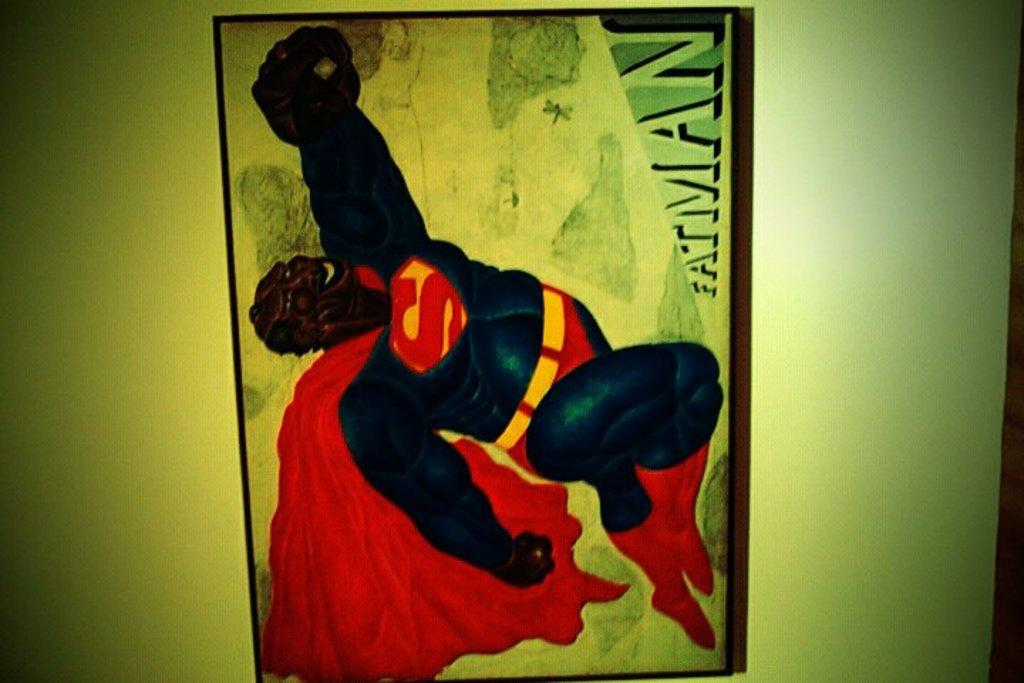<image>
Share a concise interpretation of the image provided. Superman poster on a wall with the word "Fatman" on it. 